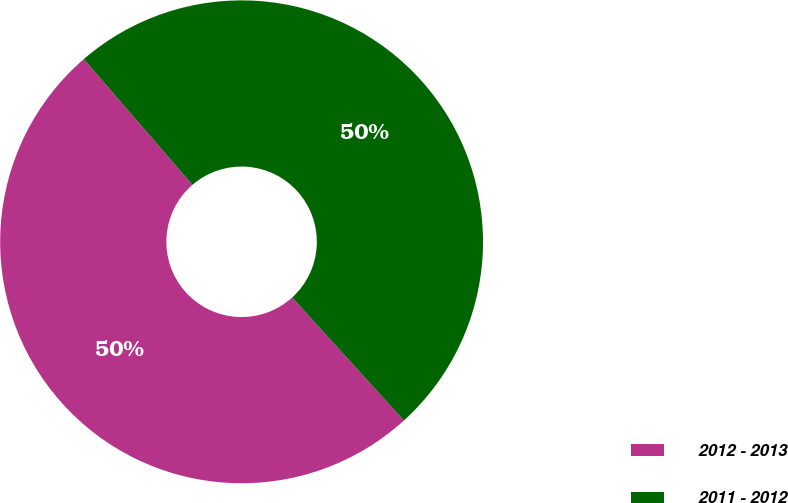Convert chart. <chart><loc_0><loc_0><loc_500><loc_500><pie_chart><fcel>2012 - 2013<fcel>2011 - 2012<nl><fcel>50.4%<fcel>49.6%<nl></chart> 